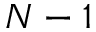<formula> <loc_0><loc_0><loc_500><loc_500>N - 1</formula> 